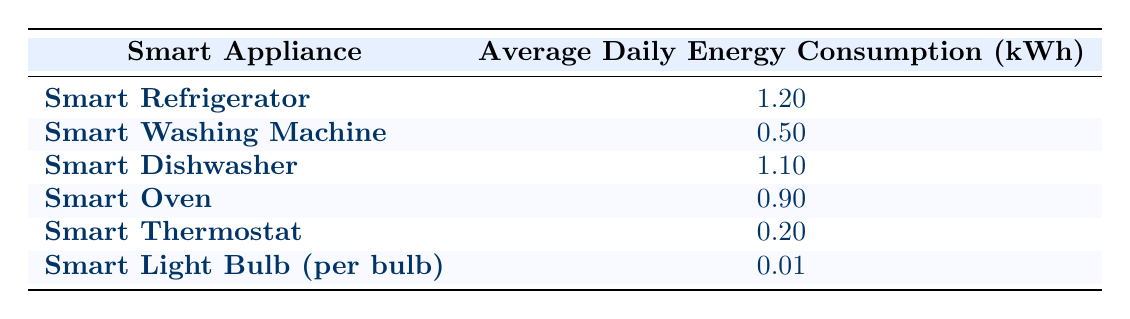What is the average daily energy consumption of a Smart Refrigerator? The table shows that the average daily energy consumption of a Smart Refrigerator is 1.2 kWh, which is listed directly under its respective row.
Answer: 1.2 kWh Which smart appliance consumes the least energy daily? By looking at the average daily energy consumption values in the table, the Smart Light Bulb consumes the least energy at 0.01 kWh.
Answer: Smart Light Bulb What is the total average daily energy consumption of the Smart Washing Machine and Smart Oven combined? To find the total, we add the average daily energy consumptions of both appliances: 0.5 kWh (Washing Machine) + 0.9 kWh (Oven) = 1.4 kWh.
Answer: 1.4 kWh Is the average daily energy consumption of a Smart Dishwasher greater than that of a Smart Thermostat? The Smart Dishwasher consumes 1.1 kWh and the Smart Thermostat consumes 0.2 kWh. Since 1.1 kWh is greater than 0.2 kWh, the statement is true.
Answer: Yes What is the average daily energy consumption of all listed smart appliances? To calculate the average, first sum the daily consumptions: 1.2 + 0.5 + 1.1 + 0.9 + 0.2 + 0.01 = 3.91 kWh. There are 6 appliances, so the average is 3.91 kWh / 6 ≈ 0.652 kWh.
Answer: 0.652 kWh Which consumes more energy daily, a Smart Refrigerator or a Smart Dishwasher? The Smart Refrigerator consumes 1.2 kWh and the Smart Dishwasher consumes 1.1 kWh. Since 1.2 kWh is greater than 1.1 kWh, the Smart Refrigerator consumes more.
Answer: Smart Refrigerator Are there any appliances that consume less than 0.2 kWh daily? Looking at the table, the Smart Thermostat consumes 0.2 kWh, while the Smart Light Bulb consumes only 0.01 kWh, meaning there are appliances that consume less than 0.2 kWh daily.
Answer: Yes What is the difference in energy consumption between the Smart Oven and Smart Dishwasher? The Smart Oven consumes 0.9 kWh and the Smart Dishwasher consumes 1.1 kWh. The difference is found by subtracting: 1.1 kWh - 0.9 kWh = 0.2 kWh.
Answer: 0.2 kWh 